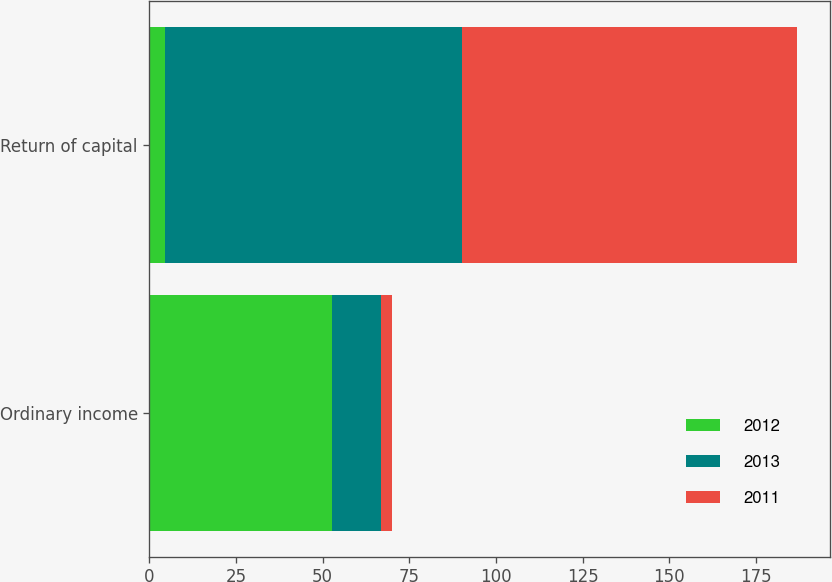<chart> <loc_0><loc_0><loc_500><loc_500><stacked_bar_chart><ecel><fcel>Ordinary income<fcel>Return of capital<nl><fcel>2012<fcel>52.6<fcel>4.4<nl><fcel>2013<fcel>14.1<fcel>85.9<nl><fcel>2011<fcel>3.3<fcel>96.7<nl></chart> 